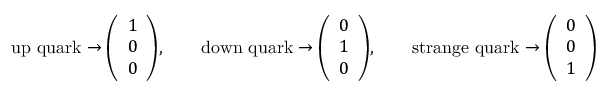<formula> <loc_0><loc_0><loc_500><loc_500>{ u p q u a r k } \rightarrow { \left ( \begin{array} { l } { 1 } \\ { 0 } \\ { 0 } \end{array} \right ) } , \quad { d o w n q u a r k } \rightarrow { \left ( \begin{array} { l } { 0 } \\ { 1 } \\ { 0 } \end{array} \right ) } , \quad { s t r a n g e q u a r k } \rightarrow { \left ( \begin{array} { l } { 0 } \\ { 0 } \\ { 1 } \end{array} \right ) }</formula> 